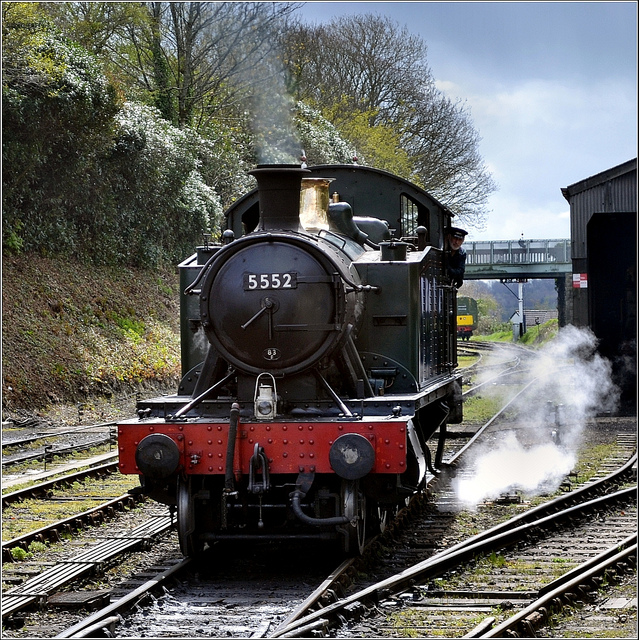Read all the text in this image. 5552 